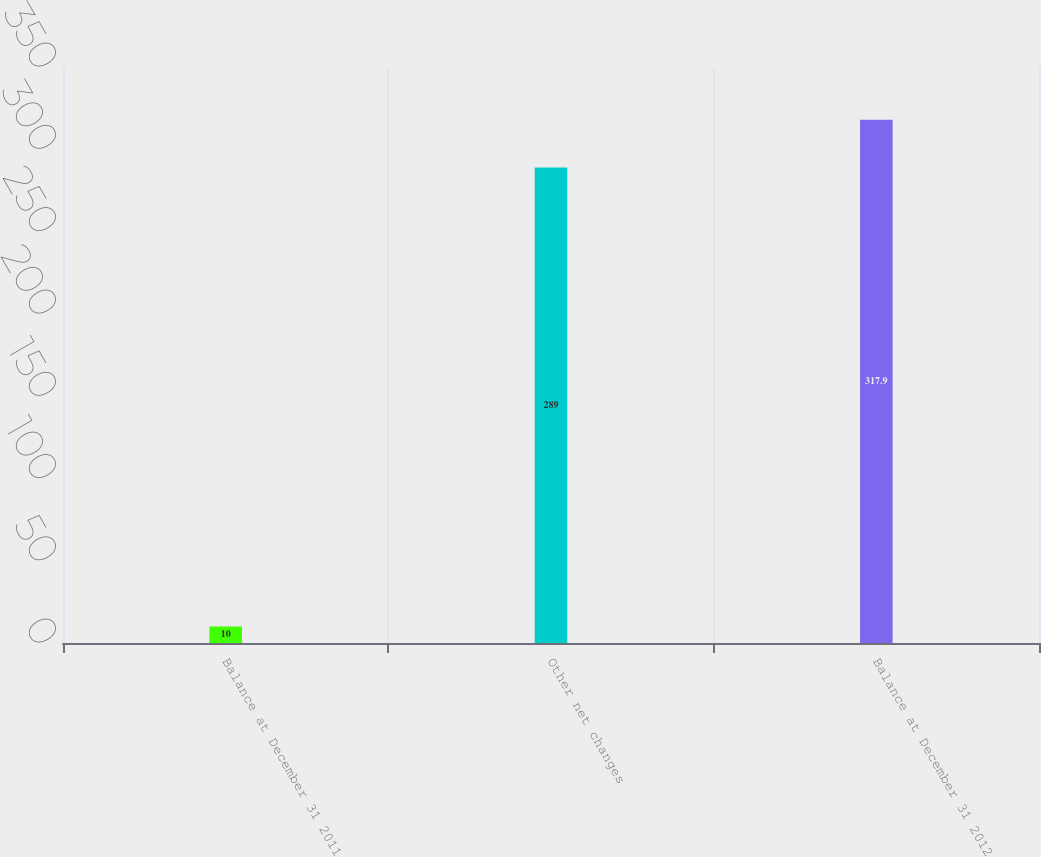Convert chart. <chart><loc_0><loc_0><loc_500><loc_500><bar_chart><fcel>Balance at December 31 2011<fcel>Other net changes<fcel>Balance at December 31 2012<nl><fcel>10<fcel>289<fcel>317.9<nl></chart> 